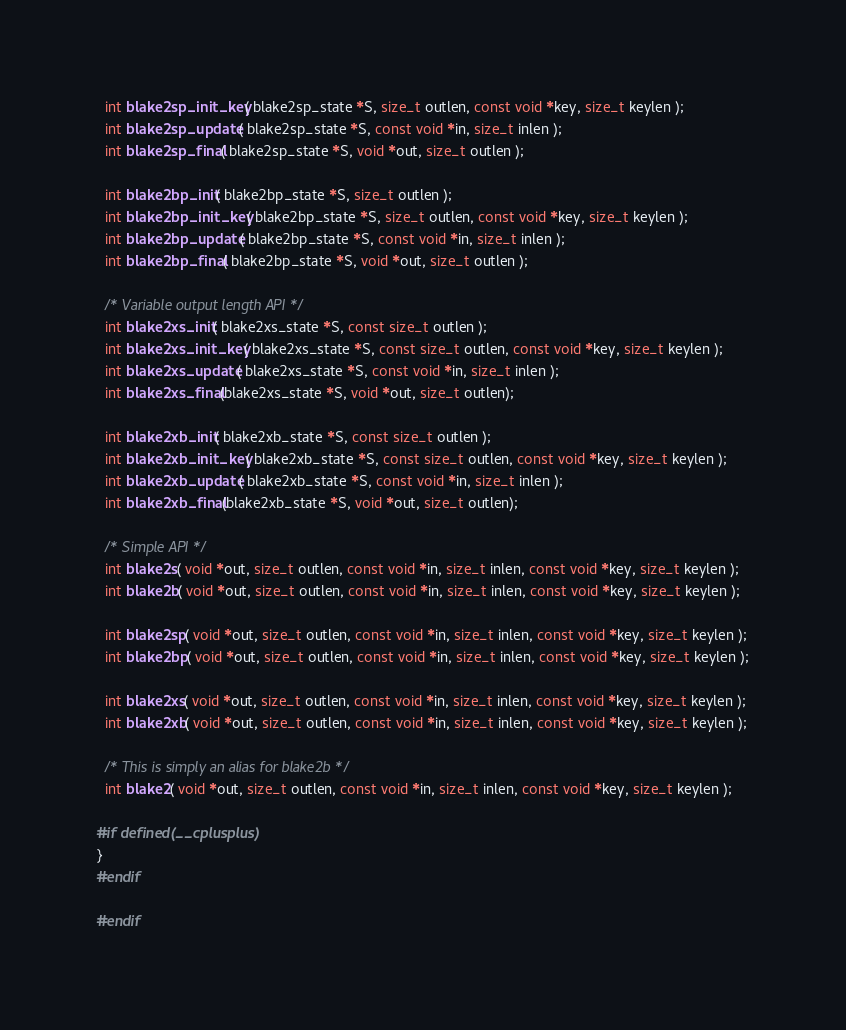Convert code to text. <code><loc_0><loc_0><loc_500><loc_500><_C_>  int blake2sp_init_key( blake2sp_state *S, size_t outlen, const void *key, size_t keylen );
  int blake2sp_update( blake2sp_state *S, const void *in, size_t inlen );
  int blake2sp_final( blake2sp_state *S, void *out, size_t outlen );

  int blake2bp_init( blake2bp_state *S, size_t outlen );
  int blake2bp_init_key( blake2bp_state *S, size_t outlen, const void *key, size_t keylen );
  int blake2bp_update( blake2bp_state *S, const void *in, size_t inlen );
  int blake2bp_final( blake2bp_state *S, void *out, size_t outlen );

  /* Variable output length API */
  int blake2xs_init( blake2xs_state *S, const size_t outlen );
  int blake2xs_init_key( blake2xs_state *S, const size_t outlen, const void *key, size_t keylen );
  int blake2xs_update( blake2xs_state *S, const void *in, size_t inlen );
  int blake2xs_final(blake2xs_state *S, void *out, size_t outlen);

  int blake2xb_init( blake2xb_state *S, const size_t outlen );
  int blake2xb_init_key( blake2xb_state *S, const size_t outlen, const void *key, size_t keylen );
  int blake2xb_update( blake2xb_state *S, const void *in, size_t inlen );
  int blake2xb_final(blake2xb_state *S, void *out, size_t outlen);

  /* Simple API */
  int blake2s( void *out, size_t outlen, const void *in, size_t inlen, const void *key, size_t keylen );
  int blake2b( void *out, size_t outlen, const void *in, size_t inlen, const void *key, size_t keylen );

  int blake2sp( void *out, size_t outlen, const void *in, size_t inlen, const void *key, size_t keylen );
  int blake2bp( void *out, size_t outlen, const void *in, size_t inlen, const void *key, size_t keylen );

  int blake2xs( void *out, size_t outlen, const void *in, size_t inlen, const void *key, size_t keylen );
  int blake2xb( void *out, size_t outlen, const void *in, size_t inlen, const void *key, size_t keylen );

  /* This is simply an alias for blake2b */
  int blake2( void *out, size_t outlen, const void *in, size_t inlen, const void *key, size_t keylen );

#if defined(__cplusplus)
}
#endif

#endif
</code> 